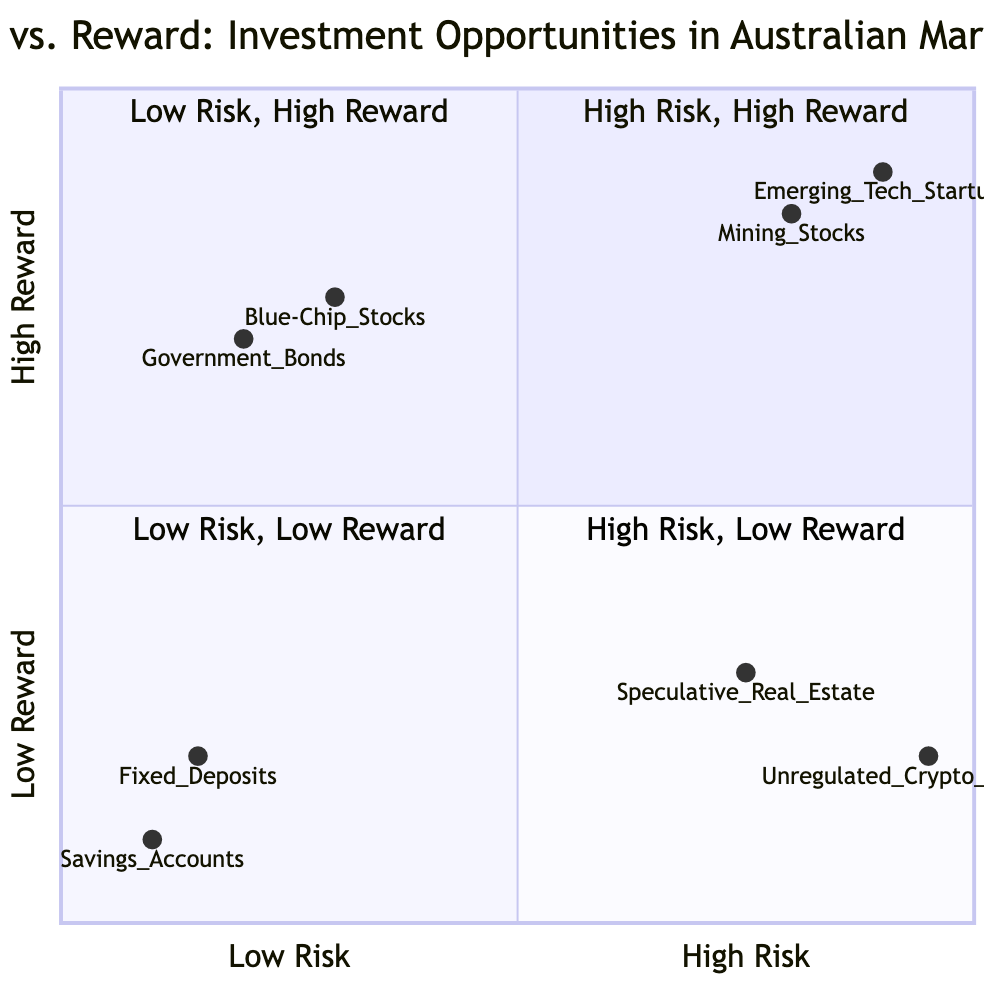What is the highest risk investment on the chart? The diagram shows multiple investments on the high-risk side, but "Emerging Tech Startups" has the highest position on the Y-axis, indicating it is the riskiest investment.
Answer: Emerging Tech Startups How many investment opportunities are categorized as Low Risk - High Reward? There are two investment opportunities listed in the Low Risk - High Reward quadrant: "Government Bonds" and "Blue-Chip Stocks".
Answer: 2 Which investment has the lowest reward potential according to the chart? "Savings Accounts" and "Fixed Deposits" are both in the Low Risk - Low Reward quadrant, but "Savings Accounts" is at the lowest point on the Y-axis, making it the lowest reward investment in the diagram.
Answer: Savings Accounts What is the reward level of Mining Stocks? The placement of "Mining Stocks" in the High Risk - High Reward quadrant shows that it has a high reward level, rated up to 0.85 on the Y-axis.
Answer: High Reward Which quadrant contains the most speculative investment opportunities? The High Risk - Low Reward quadrant contains investments considered speculative, such as "Unregulated Cryptocurrency Exchanges" and "Speculative Real Estate".
Answer: High Risk - Low Reward Which investment offers safety with modest returns? "Fixed Deposits" are noted in the Low Risk - Low Reward quadrant as a safe investment with modest returns, further supporting its categorization.
Answer: Fixed Deposits How many investments are portrayed in the High Risk - High Reward quadrant? The High Risk - High Reward quadrant features two distinct investments: "Mining Stocks" and "Emerging Tech Startups".
Answer: 2 What is the relationship between Government Bonds and Blue-Chip Stocks in terms of risk? Both "Government Bonds" and "Blue-Chip Stocks" are categorized in the Low Risk - High Reward quadrant, indicating they share a similar low risk profile.
Answer: Similar risk Which investment has a higher risk profile: Speculative Real Estate or Unregulated Cryptocurrency Exchanges? The "Unregulated Cryptocurrency Exchanges" are placed higher on the risk scale than "Speculative Real Estate", making them riskier based on their positions in the quadrants.
Answer: Unregulated Cryptocurrency Exchanges How does the investment in Blue-Chip Stocks compare to Government Bonds regarding their reward potential? Both investments are in the Low Risk - High Reward quadrant; however, "Blue-Chip Stocks" might provide slightly higher reward potential than Government Bonds, rated at 0.75 compared to 0.7.
Answer: Higher 